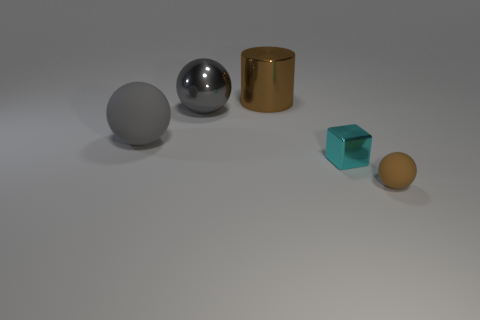There is a gray metal ball; is its size the same as the brown metal cylinder on the right side of the gray metallic thing?
Ensure brevity in your answer.  Yes. Are there fewer gray metallic objects right of the large gray metallic ball than big gray rubber objects?
Make the answer very short. Yes. What number of small objects are the same color as the cylinder?
Your answer should be compact. 1. Are there fewer tiny objects than objects?
Your answer should be compact. Yes. Is the material of the big brown thing the same as the small cyan object?
Make the answer very short. Yes. What number of other things are the same size as the brown metallic cylinder?
Ensure brevity in your answer.  2. What is the color of the matte ball that is on the right side of the brown object on the left side of the small brown thing?
Your answer should be compact. Brown. What number of other things are the same shape as the tiny brown thing?
Your response must be concise. 2. Is there a big sphere that has the same material as the tiny sphere?
Ensure brevity in your answer.  Yes. There is a cyan cube that is the same size as the brown rubber object; what is its material?
Ensure brevity in your answer.  Metal. 